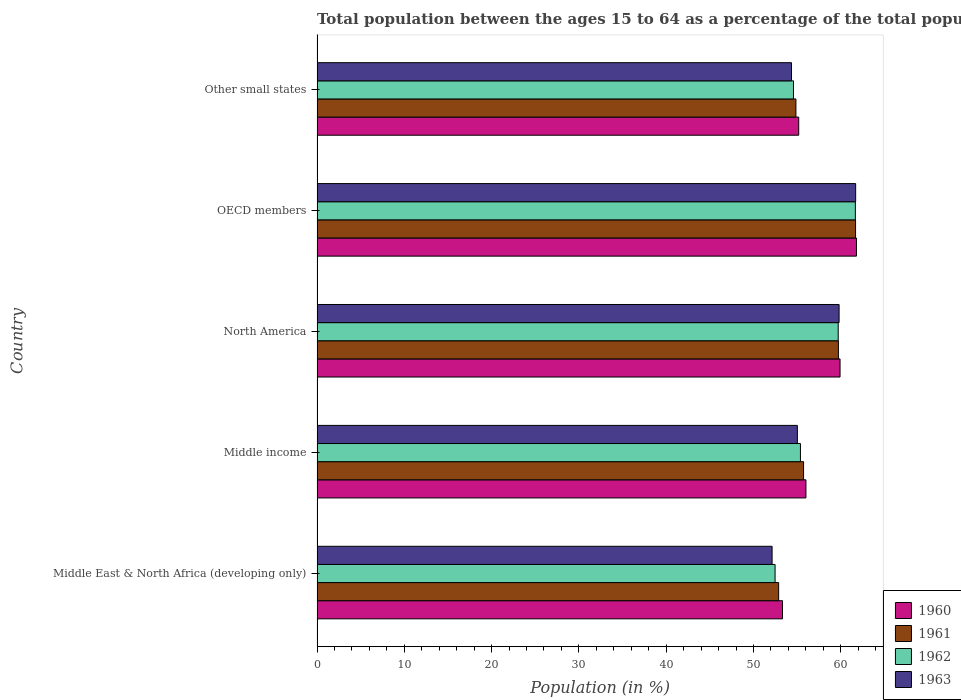How many groups of bars are there?
Offer a very short reply. 5. Are the number of bars per tick equal to the number of legend labels?
Your answer should be compact. Yes. How many bars are there on the 1st tick from the bottom?
Make the answer very short. 4. What is the label of the 1st group of bars from the top?
Your answer should be compact. Other small states. In how many cases, is the number of bars for a given country not equal to the number of legend labels?
Your answer should be very brief. 0. What is the percentage of the population ages 15 to 64 in 1960 in Middle income?
Your response must be concise. 56.01. Across all countries, what is the maximum percentage of the population ages 15 to 64 in 1962?
Your answer should be compact. 61.67. Across all countries, what is the minimum percentage of the population ages 15 to 64 in 1961?
Your response must be concise. 52.88. In which country was the percentage of the population ages 15 to 64 in 1960 minimum?
Make the answer very short. Middle East & North Africa (developing only). What is the total percentage of the population ages 15 to 64 in 1963 in the graph?
Provide a succinct answer. 283.04. What is the difference between the percentage of the population ages 15 to 64 in 1962 in Middle East & North Africa (developing only) and that in North America?
Your answer should be very brief. -7.23. What is the difference between the percentage of the population ages 15 to 64 in 1962 in Middle income and the percentage of the population ages 15 to 64 in 1960 in Middle East & North Africa (developing only)?
Provide a succinct answer. 2.06. What is the average percentage of the population ages 15 to 64 in 1963 per country?
Offer a terse response. 56.61. What is the difference between the percentage of the population ages 15 to 64 in 1961 and percentage of the population ages 15 to 64 in 1963 in OECD members?
Ensure brevity in your answer.  -0.01. What is the ratio of the percentage of the population ages 15 to 64 in 1963 in North America to that in OECD members?
Provide a succinct answer. 0.97. Is the percentage of the population ages 15 to 64 in 1960 in Middle income less than that in Other small states?
Offer a very short reply. No. What is the difference between the highest and the second highest percentage of the population ages 15 to 64 in 1963?
Provide a short and direct response. 1.9. What is the difference between the highest and the lowest percentage of the population ages 15 to 64 in 1963?
Your answer should be compact. 9.57. In how many countries, is the percentage of the population ages 15 to 64 in 1962 greater than the average percentage of the population ages 15 to 64 in 1962 taken over all countries?
Give a very brief answer. 2. Is the sum of the percentage of the population ages 15 to 64 in 1963 in North America and OECD members greater than the maximum percentage of the population ages 15 to 64 in 1961 across all countries?
Give a very brief answer. Yes. What does the 1st bar from the top in Other small states represents?
Your answer should be very brief. 1963. What does the 2nd bar from the bottom in Other small states represents?
Provide a succinct answer. 1961. Is it the case that in every country, the sum of the percentage of the population ages 15 to 64 in 1963 and percentage of the population ages 15 to 64 in 1962 is greater than the percentage of the population ages 15 to 64 in 1961?
Provide a short and direct response. Yes. Does the graph contain any zero values?
Your answer should be compact. No. Where does the legend appear in the graph?
Your answer should be compact. Bottom right. What is the title of the graph?
Offer a terse response. Total population between the ages 15 to 64 as a percentage of the total population. What is the label or title of the Y-axis?
Offer a terse response. Country. What is the Population (in %) of 1960 in Middle East & North Africa (developing only)?
Make the answer very short. 53.32. What is the Population (in %) in 1961 in Middle East & North Africa (developing only)?
Keep it short and to the point. 52.88. What is the Population (in %) of 1962 in Middle East & North Africa (developing only)?
Provide a succinct answer. 52.48. What is the Population (in %) in 1963 in Middle East & North Africa (developing only)?
Keep it short and to the point. 52.13. What is the Population (in %) in 1960 in Middle income?
Your answer should be compact. 56.01. What is the Population (in %) of 1961 in Middle income?
Your response must be concise. 55.74. What is the Population (in %) of 1962 in Middle income?
Make the answer very short. 55.38. What is the Population (in %) of 1963 in Middle income?
Ensure brevity in your answer.  55.03. What is the Population (in %) in 1960 in North America?
Make the answer very short. 59.92. What is the Population (in %) of 1961 in North America?
Ensure brevity in your answer.  59.73. What is the Population (in %) of 1962 in North America?
Provide a short and direct response. 59.71. What is the Population (in %) of 1963 in North America?
Provide a succinct answer. 59.81. What is the Population (in %) of 1960 in OECD members?
Make the answer very short. 61.8. What is the Population (in %) of 1961 in OECD members?
Provide a short and direct response. 61.7. What is the Population (in %) in 1962 in OECD members?
Your answer should be very brief. 61.67. What is the Population (in %) of 1963 in OECD members?
Ensure brevity in your answer.  61.71. What is the Population (in %) in 1960 in Other small states?
Offer a terse response. 55.18. What is the Population (in %) in 1961 in Other small states?
Offer a terse response. 54.86. What is the Population (in %) of 1962 in Other small states?
Your answer should be compact. 54.58. What is the Population (in %) of 1963 in Other small states?
Your answer should be compact. 54.36. Across all countries, what is the maximum Population (in %) in 1960?
Give a very brief answer. 61.8. Across all countries, what is the maximum Population (in %) of 1961?
Provide a succinct answer. 61.7. Across all countries, what is the maximum Population (in %) in 1962?
Keep it short and to the point. 61.67. Across all countries, what is the maximum Population (in %) in 1963?
Provide a short and direct response. 61.71. Across all countries, what is the minimum Population (in %) in 1960?
Your response must be concise. 53.32. Across all countries, what is the minimum Population (in %) in 1961?
Offer a terse response. 52.88. Across all countries, what is the minimum Population (in %) of 1962?
Provide a succinct answer. 52.48. Across all countries, what is the minimum Population (in %) in 1963?
Your response must be concise. 52.13. What is the total Population (in %) of 1960 in the graph?
Offer a very short reply. 286.24. What is the total Population (in %) in 1961 in the graph?
Your answer should be very brief. 284.92. What is the total Population (in %) of 1962 in the graph?
Offer a terse response. 283.82. What is the total Population (in %) in 1963 in the graph?
Give a very brief answer. 283.04. What is the difference between the Population (in %) in 1960 in Middle East & North Africa (developing only) and that in Middle income?
Your response must be concise. -2.69. What is the difference between the Population (in %) in 1961 in Middle East & North Africa (developing only) and that in Middle income?
Make the answer very short. -2.86. What is the difference between the Population (in %) in 1962 in Middle East & North Africa (developing only) and that in Middle income?
Keep it short and to the point. -2.9. What is the difference between the Population (in %) of 1963 in Middle East & North Africa (developing only) and that in Middle income?
Your answer should be very brief. -2.9. What is the difference between the Population (in %) of 1960 in Middle East & North Africa (developing only) and that in North America?
Ensure brevity in your answer.  -6.59. What is the difference between the Population (in %) of 1961 in Middle East & North Africa (developing only) and that in North America?
Keep it short and to the point. -6.85. What is the difference between the Population (in %) in 1962 in Middle East & North Africa (developing only) and that in North America?
Your answer should be compact. -7.23. What is the difference between the Population (in %) of 1963 in Middle East & North Africa (developing only) and that in North America?
Provide a succinct answer. -7.68. What is the difference between the Population (in %) of 1960 in Middle East & North Africa (developing only) and that in OECD members?
Ensure brevity in your answer.  -8.48. What is the difference between the Population (in %) in 1961 in Middle East & North Africa (developing only) and that in OECD members?
Your answer should be compact. -8.81. What is the difference between the Population (in %) of 1962 in Middle East & North Africa (developing only) and that in OECD members?
Give a very brief answer. -9.2. What is the difference between the Population (in %) in 1963 in Middle East & North Africa (developing only) and that in OECD members?
Give a very brief answer. -9.57. What is the difference between the Population (in %) of 1960 in Middle East & North Africa (developing only) and that in Other small states?
Give a very brief answer. -1.86. What is the difference between the Population (in %) in 1961 in Middle East & North Africa (developing only) and that in Other small states?
Your answer should be very brief. -1.98. What is the difference between the Population (in %) in 1962 in Middle East & North Africa (developing only) and that in Other small states?
Make the answer very short. -2.11. What is the difference between the Population (in %) in 1963 in Middle East & North Africa (developing only) and that in Other small states?
Your answer should be very brief. -2.22. What is the difference between the Population (in %) in 1960 in Middle income and that in North America?
Provide a short and direct response. -3.91. What is the difference between the Population (in %) of 1961 in Middle income and that in North America?
Keep it short and to the point. -3.99. What is the difference between the Population (in %) in 1962 in Middle income and that in North America?
Provide a succinct answer. -4.33. What is the difference between the Population (in %) of 1963 in Middle income and that in North America?
Offer a very short reply. -4.78. What is the difference between the Population (in %) in 1960 in Middle income and that in OECD members?
Keep it short and to the point. -5.79. What is the difference between the Population (in %) in 1961 in Middle income and that in OECD members?
Provide a succinct answer. -5.96. What is the difference between the Population (in %) in 1962 in Middle income and that in OECD members?
Give a very brief answer. -6.29. What is the difference between the Population (in %) of 1963 in Middle income and that in OECD members?
Your answer should be compact. -6.68. What is the difference between the Population (in %) in 1960 in Middle income and that in Other small states?
Offer a very short reply. 0.83. What is the difference between the Population (in %) in 1961 in Middle income and that in Other small states?
Your response must be concise. 0.88. What is the difference between the Population (in %) in 1962 in Middle income and that in Other small states?
Your answer should be very brief. 0.8. What is the difference between the Population (in %) in 1963 in Middle income and that in Other small states?
Provide a succinct answer. 0.67. What is the difference between the Population (in %) in 1960 in North America and that in OECD members?
Your answer should be very brief. -1.88. What is the difference between the Population (in %) of 1961 in North America and that in OECD members?
Your answer should be compact. -1.96. What is the difference between the Population (in %) in 1962 in North America and that in OECD members?
Ensure brevity in your answer.  -1.97. What is the difference between the Population (in %) of 1963 in North America and that in OECD members?
Your answer should be very brief. -1.9. What is the difference between the Population (in %) in 1960 in North America and that in Other small states?
Offer a very short reply. 4.74. What is the difference between the Population (in %) in 1961 in North America and that in Other small states?
Offer a very short reply. 4.87. What is the difference between the Population (in %) in 1962 in North America and that in Other small states?
Provide a succinct answer. 5.12. What is the difference between the Population (in %) in 1963 in North America and that in Other small states?
Provide a succinct answer. 5.45. What is the difference between the Population (in %) in 1960 in OECD members and that in Other small states?
Offer a very short reply. 6.62. What is the difference between the Population (in %) of 1961 in OECD members and that in Other small states?
Provide a succinct answer. 6.83. What is the difference between the Population (in %) of 1962 in OECD members and that in Other small states?
Provide a short and direct response. 7.09. What is the difference between the Population (in %) in 1963 in OECD members and that in Other small states?
Make the answer very short. 7.35. What is the difference between the Population (in %) in 1960 in Middle East & North Africa (developing only) and the Population (in %) in 1961 in Middle income?
Make the answer very short. -2.42. What is the difference between the Population (in %) in 1960 in Middle East & North Africa (developing only) and the Population (in %) in 1962 in Middle income?
Keep it short and to the point. -2.06. What is the difference between the Population (in %) in 1960 in Middle East & North Africa (developing only) and the Population (in %) in 1963 in Middle income?
Keep it short and to the point. -1.71. What is the difference between the Population (in %) of 1961 in Middle East & North Africa (developing only) and the Population (in %) of 1962 in Middle income?
Keep it short and to the point. -2.5. What is the difference between the Population (in %) of 1961 in Middle East & North Africa (developing only) and the Population (in %) of 1963 in Middle income?
Make the answer very short. -2.15. What is the difference between the Population (in %) in 1962 in Middle East & North Africa (developing only) and the Population (in %) in 1963 in Middle income?
Give a very brief answer. -2.55. What is the difference between the Population (in %) in 1960 in Middle East & North Africa (developing only) and the Population (in %) in 1961 in North America?
Provide a succinct answer. -6.41. What is the difference between the Population (in %) in 1960 in Middle East & North Africa (developing only) and the Population (in %) in 1962 in North America?
Your response must be concise. -6.38. What is the difference between the Population (in %) in 1960 in Middle East & North Africa (developing only) and the Population (in %) in 1963 in North America?
Your answer should be compact. -6.49. What is the difference between the Population (in %) in 1961 in Middle East & North Africa (developing only) and the Population (in %) in 1962 in North America?
Make the answer very short. -6.82. What is the difference between the Population (in %) in 1961 in Middle East & North Africa (developing only) and the Population (in %) in 1963 in North America?
Ensure brevity in your answer.  -6.93. What is the difference between the Population (in %) in 1962 in Middle East & North Africa (developing only) and the Population (in %) in 1963 in North America?
Your answer should be very brief. -7.33. What is the difference between the Population (in %) in 1960 in Middle East & North Africa (developing only) and the Population (in %) in 1961 in OECD members?
Provide a succinct answer. -8.37. What is the difference between the Population (in %) of 1960 in Middle East & North Africa (developing only) and the Population (in %) of 1962 in OECD members?
Ensure brevity in your answer.  -8.35. What is the difference between the Population (in %) of 1960 in Middle East & North Africa (developing only) and the Population (in %) of 1963 in OECD members?
Offer a very short reply. -8.38. What is the difference between the Population (in %) of 1961 in Middle East & North Africa (developing only) and the Population (in %) of 1962 in OECD members?
Your response must be concise. -8.79. What is the difference between the Population (in %) of 1961 in Middle East & North Africa (developing only) and the Population (in %) of 1963 in OECD members?
Your answer should be compact. -8.82. What is the difference between the Population (in %) of 1962 in Middle East & North Africa (developing only) and the Population (in %) of 1963 in OECD members?
Make the answer very short. -9.23. What is the difference between the Population (in %) of 1960 in Middle East & North Africa (developing only) and the Population (in %) of 1961 in Other small states?
Provide a succinct answer. -1.54. What is the difference between the Population (in %) of 1960 in Middle East & North Africa (developing only) and the Population (in %) of 1962 in Other small states?
Your response must be concise. -1.26. What is the difference between the Population (in %) of 1960 in Middle East & North Africa (developing only) and the Population (in %) of 1963 in Other small states?
Give a very brief answer. -1.03. What is the difference between the Population (in %) in 1961 in Middle East & North Africa (developing only) and the Population (in %) in 1962 in Other small states?
Offer a terse response. -1.7. What is the difference between the Population (in %) of 1961 in Middle East & North Africa (developing only) and the Population (in %) of 1963 in Other small states?
Ensure brevity in your answer.  -1.48. What is the difference between the Population (in %) in 1962 in Middle East & North Africa (developing only) and the Population (in %) in 1963 in Other small states?
Your answer should be very brief. -1.88. What is the difference between the Population (in %) of 1960 in Middle income and the Population (in %) of 1961 in North America?
Provide a succinct answer. -3.72. What is the difference between the Population (in %) of 1960 in Middle income and the Population (in %) of 1962 in North America?
Your answer should be very brief. -3.7. What is the difference between the Population (in %) of 1960 in Middle income and the Population (in %) of 1963 in North America?
Your answer should be compact. -3.8. What is the difference between the Population (in %) of 1961 in Middle income and the Population (in %) of 1962 in North America?
Offer a terse response. -3.97. What is the difference between the Population (in %) in 1961 in Middle income and the Population (in %) in 1963 in North America?
Give a very brief answer. -4.07. What is the difference between the Population (in %) of 1962 in Middle income and the Population (in %) of 1963 in North America?
Make the answer very short. -4.43. What is the difference between the Population (in %) in 1960 in Middle income and the Population (in %) in 1961 in OECD members?
Keep it short and to the point. -5.69. What is the difference between the Population (in %) in 1960 in Middle income and the Population (in %) in 1962 in OECD members?
Provide a succinct answer. -5.66. What is the difference between the Population (in %) of 1960 in Middle income and the Population (in %) of 1963 in OECD members?
Give a very brief answer. -5.7. What is the difference between the Population (in %) in 1961 in Middle income and the Population (in %) in 1962 in OECD members?
Keep it short and to the point. -5.93. What is the difference between the Population (in %) in 1961 in Middle income and the Population (in %) in 1963 in OECD members?
Offer a very short reply. -5.97. What is the difference between the Population (in %) of 1962 in Middle income and the Population (in %) of 1963 in OECD members?
Your response must be concise. -6.33. What is the difference between the Population (in %) in 1960 in Middle income and the Population (in %) in 1961 in Other small states?
Provide a short and direct response. 1.15. What is the difference between the Population (in %) of 1960 in Middle income and the Population (in %) of 1962 in Other small states?
Ensure brevity in your answer.  1.43. What is the difference between the Population (in %) in 1960 in Middle income and the Population (in %) in 1963 in Other small states?
Your answer should be compact. 1.65. What is the difference between the Population (in %) in 1961 in Middle income and the Population (in %) in 1962 in Other small states?
Your response must be concise. 1.16. What is the difference between the Population (in %) of 1961 in Middle income and the Population (in %) of 1963 in Other small states?
Ensure brevity in your answer.  1.38. What is the difference between the Population (in %) in 1962 in Middle income and the Population (in %) in 1963 in Other small states?
Your answer should be compact. 1.02. What is the difference between the Population (in %) in 1960 in North America and the Population (in %) in 1961 in OECD members?
Your answer should be very brief. -1.78. What is the difference between the Population (in %) in 1960 in North America and the Population (in %) in 1962 in OECD members?
Offer a very short reply. -1.75. What is the difference between the Population (in %) in 1960 in North America and the Population (in %) in 1963 in OECD members?
Your answer should be compact. -1.79. What is the difference between the Population (in %) of 1961 in North America and the Population (in %) of 1962 in OECD members?
Provide a succinct answer. -1.94. What is the difference between the Population (in %) in 1961 in North America and the Population (in %) in 1963 in OECD members?
Your response must be concise. -1.98. What is the difference between the Population (in %) of 1962 in North America and the Population (in %) of 1963 in OECD members?
Your answer should be compact. -2. What is the difference between the Population (in %) in 1960 in North America and the Population (in %) in 1961 in Other small states?
Ensure brevity in your answer.  5.05. What is the difference between the Population (in %) of 1960 in North America and the Population (in %) of 1962 in Other small states?
Offer a terse response. 5.34. What is the difference between the Population (in %) of 1960 in North America and the Population (in %) of 1963 in Other small states?
Your response must be concise. 5.56. What is the difference between the Population (in %) in 1961 in North America and the Population (in %) in 1962 in Other small states?
Make the answer very short. 5.15. What is the difference between the Population (in %) of 1961 in North America and the Population (in %) of 1963 in Other small states?
Your answer should be very brief. 5.37. What is the difference between the Population (in %) in 1962 in North America and the Population (in %) in 1963 in Other small states?
Ensure brevity in your answer.  5.35. What is the difference between the Population (in %) of 1960 in OECD members and the Population (in %) of 1961 in Other small states?
Ensure brevity in your answer.  6.94. What is the difference between the Population (in %) of 1960 in OECD members and the Population (in %) of 1962 in Other small states?
Ensure brevity in your answer.  7.22. What is the difference between the Population (in %) of 1960 in OECD members and the Population (in %) of 1963 in Other small states?
Your answer should be very brief. 7.44. What is the difference between the Population (in %) in 1961 in OECD members and the Population (in %) in 1962 in Other small states?
Your response must be concise. 7.11. What is the difference between the Population (in %) of 1961 in OECD members and the Population (in %) of 1963 in Other small states?
Your answer should be compact. 7.34. What is the difference between the Population (in %) in 1962 in OECD members and the Population (in %) in 1963 in Other small states?
Offer a terse response. 7.31. What is the average Population (in %) in 1960 per country?
Offer a very short reply. 57.25. What is the average Population (in %) of 1961 per country?
Keep it short and to the point. 56.98. What is the average Population (in %) in 1962 per country?
Your response must be concise. 56.76. What is the average Population (in %) in 1963 per country?
Your answer should be compact. 56.61. What is the difference between the Population (in %) of 1960 and Population (in %) of 1961 in Middle East & North Africa (developing only)?
Give a very brief answer. 0.44. What is the difference between the Population (in %) of 1960 and Population (in %) of 1962 in Middle East & North Africa (developing only)?
Make the answer very short. 0.85. What is the difference between the Population (in %) in 1960 and Population (in %) in 1963 in Middle East & North Africa (developing only)?
Make the answer very short. 1.19. What is the difference between the Population (in %) of 1961 and Population (in %) of 1962 in Middle East & North Africa (developing only)?
Offer a terse response. 0.41. What is the difference between the Population (in %) of 1961 and Population (in %) of 1963 in Middle East & North Africa (developing only)?
Provide a succinct answer. 0.75. What is the difference between the Population (in %) of 1962 and Population (in %) of 1963 in Middle East & North Africa (developing only)?
Provide a short and direct response. 0.34. What is the difference between the Population (in %) in 1960 and Population (in %) in 1961 in Middle income?
Keep it short and to the point. 0.27. What is the difference between the Population (in %) in 1960 and Population (in %) in 1962 in Middle income?
Make the answer very short. 0.63. What is the difference between the Population (in %) in 1960 and Population (in %) in 1963 in Middle income?
Keep it short and to the point. 0.98. What is the difference between the Population (in %) of 1961 and Population (in %) of 1962 in Middle income?
Provide a succinct answer. 0.36. What is the difference between the Population (in %) in 1961 and Population (in %) in 1963 in Middle income?
Give a very brief answer. 0.71. What is the difference between the Population (in %) of 1962 and Population (in %) of 1963 in Middle income?
Offer a terse response. 0.35. What is the difference between the Population (in %) in 1960 and Population (in %) in 1961 in North America?
Make the answer very short. 0.19. What is the difference between the Population (in %) of 1960 and Population (in %) of 1962 in North America?
Provide a succinct answer. 0.21. What is the difference between the Population (in %) of 1960 and Population (in %) of 1963 in North America?
Keep it short and to the point. 0.11. What is the difference between the Population (in %) of 1961 and Population (in %) of 1962 in North America?
Keep it short and to the point. 0.02. What is the difference between the Population (in %) in 1961 and Population (in %) in 1963 in North America?
Keep it short and to the point. -0.08. What is the difference between the Population (in %) in 1962 and Population (in %) in 1963 in North America?
Keep it short and to the point. -0.1. What is the difference between the Population (in %) in 1960 and Population (in %) in 1961 in OECD members?
Your answer should be very brief. 0.1. What is the difference between the Population (in %) of 1960 and Population (in %) of 1962 in OECD members?
Your answer should be very brief. 0.13. What is the difference between the Population (in %) of 1960 and Population (in %) of 1963 in OECD members?
Your answer should be compact. 0.09. What is the difference between the Population (in %) of 1961 and Population (in %) of 1962 in OECD members?
Your answer should be very brief. 0.02. What is the difference between the Population (in %) of 1961 and Population (in %) of 1963 in OECD members?
Provide a short and direct response. -0.01. What is the difference between the Population (in %) in 1962 and Population (in %) in 1963 in OECD members?
Offer a very short reply. -0.04. What is the difference between the Population (in %) in 1960 and Population (in %) in 1961 in Other small states?
Provide a succinct answer. 0.32. What is the difference between the Population (in %) in 1960 and Population (in %) in 1962 in Other small states?
Provide a short and direct response. 0.6. What is the difference between the Population (in %) of 1960 and Population (in %) of 1963 in Other small states?
Give a very brief answer. 0.82. What is the difference between the Population (in %) of 1961 and Population (in %) of 1962 in Other small states?
Offer a very short reply. 0.28. What is the difference between the Population (in %) in 1961 and Population (in %) in 1963 in Other small states?
Your answer should be compact. 0.51. What is the difference between the Population (in %) of 1962 and Population (in %) of 1963 in Other small states?
Offer a terse response. 0.22. What is the ratio of the Population (in %) of 1960 in Middle East & North Africa (developing only) to that in Middle income?
Provide a short and direct response. 0.95. What is the ratio of the Population (in %) of 1961 in Middle East & North Africa (developing only) to that in Middle income?
Keep it short and to the point. 0.95. What is the ratio of the Population (in %) of 1962 in Middle East & North Africa (developing only) to that in Middle income?
Provide a succinct answer. 0.95. What is the ratio of the Population (in %) in 1963 in Middle East & North Africa (developing only) to that in Middle income?
Your answer should be compact. 0.95. What is the ratio of the Population (in %) in 1960 in Middle East & North Africa (developing only) to that in North America?
Provide a short and direct response. 0.89. What is the ratio of the Population (in %) of 1961 in Middle East & North Africa (developing only) to that in North America?
Your answer should be compact. 0.89. What is the ratio of the Population (in %) of 1962 in Middle East & North Africa (developing only) to that in North America?
Provide a succinct answer. 0.88. What is the ratio of the Population (in %) of 1963 in Middle East & North Africa (developing only) to that in North America?
Provide a short and direct response. 0.87. What is the ratio of the Population (in %) in 1960 in Middle East & North Africa (developing only) to that in OECD members?
Ensure brevity in your answer.  0.86. What is the ratio of the Population (in %) in 1961 in Middle East & North Africa (developing only) to that in OECD members?
Offer a very short reply. 0.86. What is the ratio of the Population (in %) in 1962 in Middle East & North Africa (developing only) to that in OECD members?
Your response must be concise. 0.85. What is the ratio of the Population (in %) of 1963 in Middle East & North Africa (developing only) to that in OECD members?
Provide a short and direct response. 0.84. What is the ratio of the Population (in %) of 1960 in Middle East & North Africa (developing only) to that in Other small states?
Your answer should be compact. 0.97. What is the ratio of the Population (in %) of 1961 in Middle East & North Africa (developing only) to that in Other small states?
Your answer should be compact. 0.96. What is the ratio of the Population (in %) of 1962 in Middle East & North Africa (developing only) to that in Other small states?
Ensure brevity in your answer.  0.96. What is the ratio of the Population (in %) in 1963 in Middle East & North Africa (developing only) to that in Other small states?
Your answer should be compact. 0.96. What is the ratio of the Population (in %) in 1960 in Middle income to that in North America?
Give a very brief answer. 0.93. What is the ratio of the Population (in %) of 1961 in Middle income to that in North America?
Your answer should be compact. 0.93. What is the ratio of the Population (in %) in 1962 in Middle income to that in North America?
Your response must be concise. 0.93. What is the ratio of the Population (in %) of 1963 in Middle income to that in North America?
Ensure brevity in your answer.  0.92. What is the ratio of the Population (in %) of 1960 in Middle income to that in OECD members?
Your response must be concise. 0.91. What is the ratio of the Population (in %) of 1961 in Middle income to that in OECD members?
Your answer should be very brief. 0.9. What is the ratio of the Population (in %) in 1962 in Middle income to that in OECD members?
Provide a succinct answer. 0.9. What is the ratio of the Population (in %) of 1963 in Middle income to that in OECD members?
Your answer should be compact. 0.89. What is the ratio of the Population (in %) of 1962 in Middle income to that in Other small states?
Provide a succinct answer. 1.01. What is the ratio of the Population (in %) in 1963 in Middle income to that in Other small states?
Your answer should be very brief. 1.01. What is the ratio of the Population (in %) in 1960 in North America to that in OECD members?
Your answer should be very brief. 0.97. What is the ratio of the Population (in %) in 1961 in North America to that in OECD members?
Keep it short and to the point. 0.97. What is the ratio of the Population (in %) in 1962 in North America to that in OECD members?
Give a very brief answer. 0.97. What is the ratio of the Population (in %) of 1963 in North America to that in OECD members?
Ensure brevity in your answer.  0.97. What is the ratio of the Population (in %) in 1960 in North America to that in Other small states?
Offer a very short reply. 1.09. What is the ratio of the Population (in %) in 1961 in North America to that in Other small states?
Your answer should be very brief. 1.09. What is the ratio of the Population (in %) of 1962 in North America to that in Other small states?
Give a very brief answer. 1.09. What is the ratio of the Population (in %) in 1963 in North America to that in Other small states?
Keep it short and to the point. 1.1. What is the ratio of the Population (in %) in 1960 in OECD members to that in Other small states?
Make the answer very short. 1.12. What is the ratio of the Population (in %) in 1961 in OECD members to that in Other small states?
Your answer should be compact. 1.12. What is the ratio of the Population (in %) of 1962 in OECD members to that in Other small states?
Provide a short and direct response. 1.13. What is the ratio of the Population (in %) of 1963 in OECD members to that in Other small states?
Make the answer very short. 1.14. What is the difference between the highest and the second highest Population (in %) in 1960?
Provide a succinct answer. 1.88. What is the difference between the highest and the second highest Population (in %) in 1961?
Your response must be concise. 1.96. What is the difference between the highest and the second highest Population (in %) in 1962?
Your response must be concise. 1.97. What is the difference between the highest and the second highest Population (in %) in 1963?
Offer a terse response. 1.9. What is the difference between the highest and the lowest Population (in %) in 1960?
Offer a very short reply. 8.48. What is the difference between the highest and the lowest Population (in %) in 1961?
Offer a terse response. 8.81. What is the difference between the highest and the lowest Population (in %) of 1962?
Offer a very short reply. 9.2. What is the difference between the highest and the lowest Population (in %) of 1963?
Your response must be concise. 9.57. 